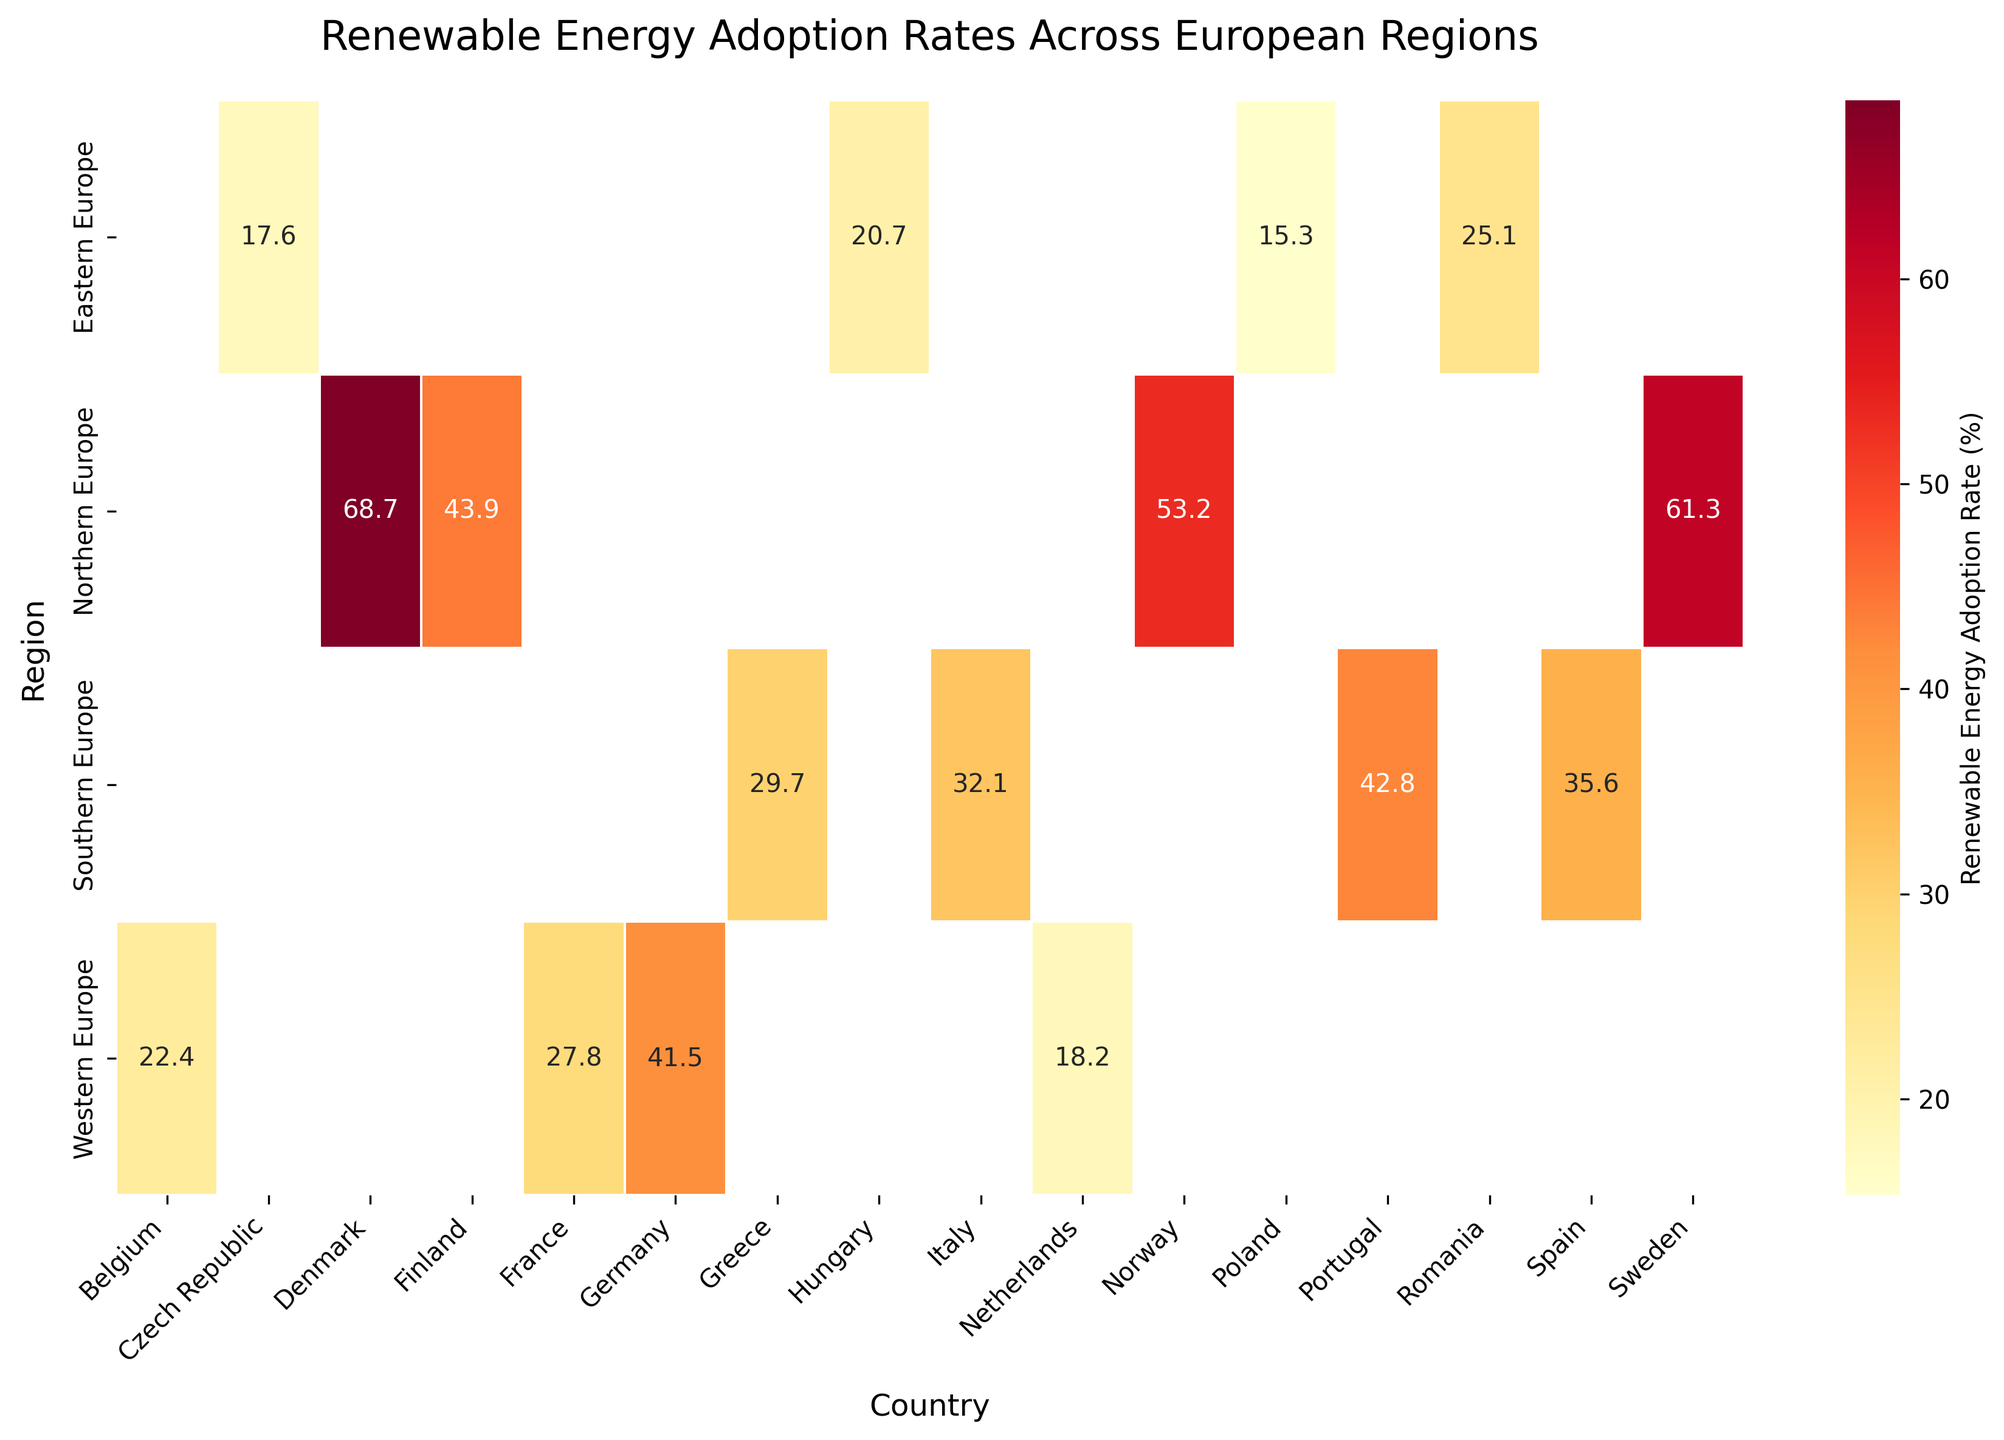What is the title of the heatmap? The title of the heatmap is positioned at the top of the figure and is formatted in larger font. It gives an overview of what the chart represents.
Answer: Renewable Energy Adoption Rates Across European Regions Which country in Northern Europe has the highest renewable energy adoption rate? By looking at the Northern Europe row in the heatmap, the country with the highest adoption rate is highlighted with the most intense color.
Answer: Denmark What is the renewable energy adoption rate in France? Locate France on the Western Europe row and read the adoption rate from the annotated value in the heatmap.
Answer: 27.8% Which region has the lowest renewable energy adoption rate, and what is the rate? Scan through the rows in the heatmap to identify the region with the lowest color intensity and note the country and rate.
Answer: Eastern Europe, 15.3% Compare the renewable energy adoption rates between Spain and Italy. Which country has a higher rate and by how much? Find Spain and Italy in the Southern Europe row, then subtract Italy's rate from Spain's rate to get the difference. Spain (35.6%) and Italy (32.1%); 35.6 - 32.1 = 3.5.
Answer: Spain, 3.5% What is the average renewable energy adoption rate for countries in Western Europe? Find the values for Germany, France, Netherlands, and Belgium in the Western Europe row and calculate their average: (41.5 + 27.8 + 18.2 + 22.4) / 4 = 109.9 / 4
Answer: 27.5% What is the range of renewable energy adoption rates in Southern Europe? Identify the minimum and maximum values in the Southern Europe row and subtract the minimum from the maximum to find the range: 42.8 - 29.7 = 13.1.
Answer: 13.1% How does the renewable energy adoption rate in Norway compare to that in Poland? Locate Norway in Northern Europe and Poland in Eastern Europe, then compare their rates. Norway (53.2%) has a higher adoption rate than Poland (15.3%).
Answer: Norway's rate is higher Which region has the most consistent renewable energy adoption rates, with the smallest variation? Assess the variability of rates within each region by comparing the intensity range of colors in each row. Northern Europe shows relatively consistent high rates with less variation than other regions.
Answer: Northern Europe 